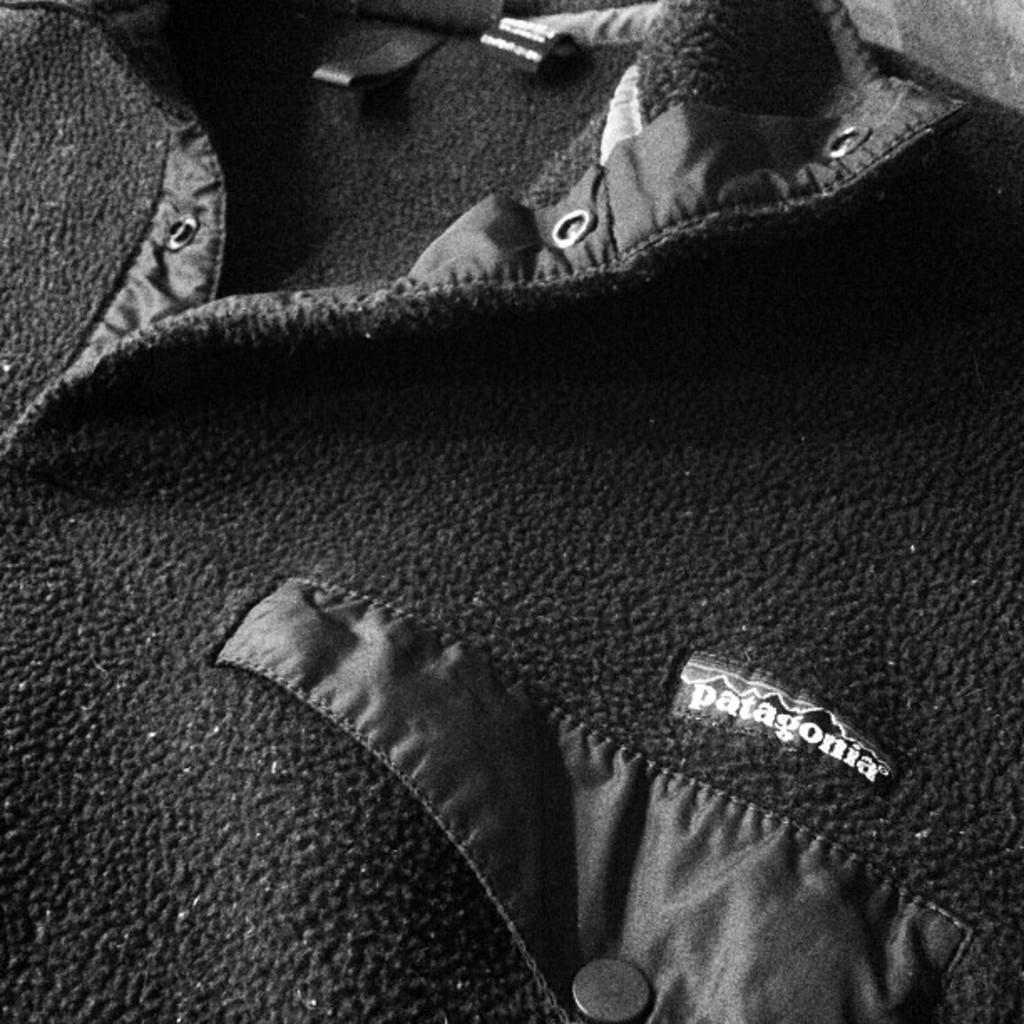What material is present in the image? There is cloth in the image. Is there any additional information about the cloth in the image? Yes, there is a tag with text on it in the image. How many boys are playing with the cloth in the image? There are no boys present in the image; it only features cloth and a tag with text on it. 